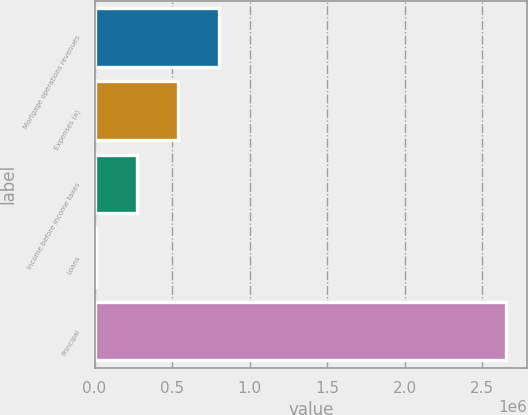<chart> <loc_0><loc_0><loc_500><loc_500><bar_chart><fcel>Mortgage operations revenues<fcel>Expenses (a)<fcel>Income before income taxes<fcel>Loans<fcel>Principal<nl><fcel>804568<fcel>539981<fcel>275393<fcel>10805<fcel>2.65668e+06<nl></chart> 